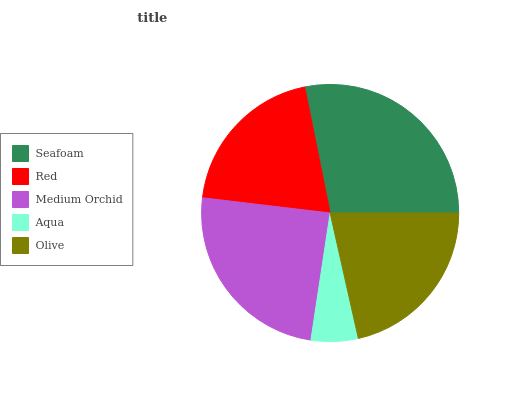Is Aqua the minimum?
Answer yes or no. Yes. Is Seafoam the maximum?
Answer yes or no. Yes. Is Red the minimum?
Answer yes or no. No. Is Red the maximum?
Answer yes or no. No. Is Seafoam greater than Red?
Answer yes or no. Yes. Is Red less than Seafoam?
Answer yes or no. Yes. Is Red greater than Seafoam?
Answer yes or no. No. Is Seafoam less than Red?
Answer yes or no. No. Is Olive the high median?
Answer yes or no. Yes. Is Olive the low median?
Answer yes or no. Yes. Is Seafoam the high median?
Answer yes or no. No. Is Medium Orchid the low median?
Answer yes or no. No. 